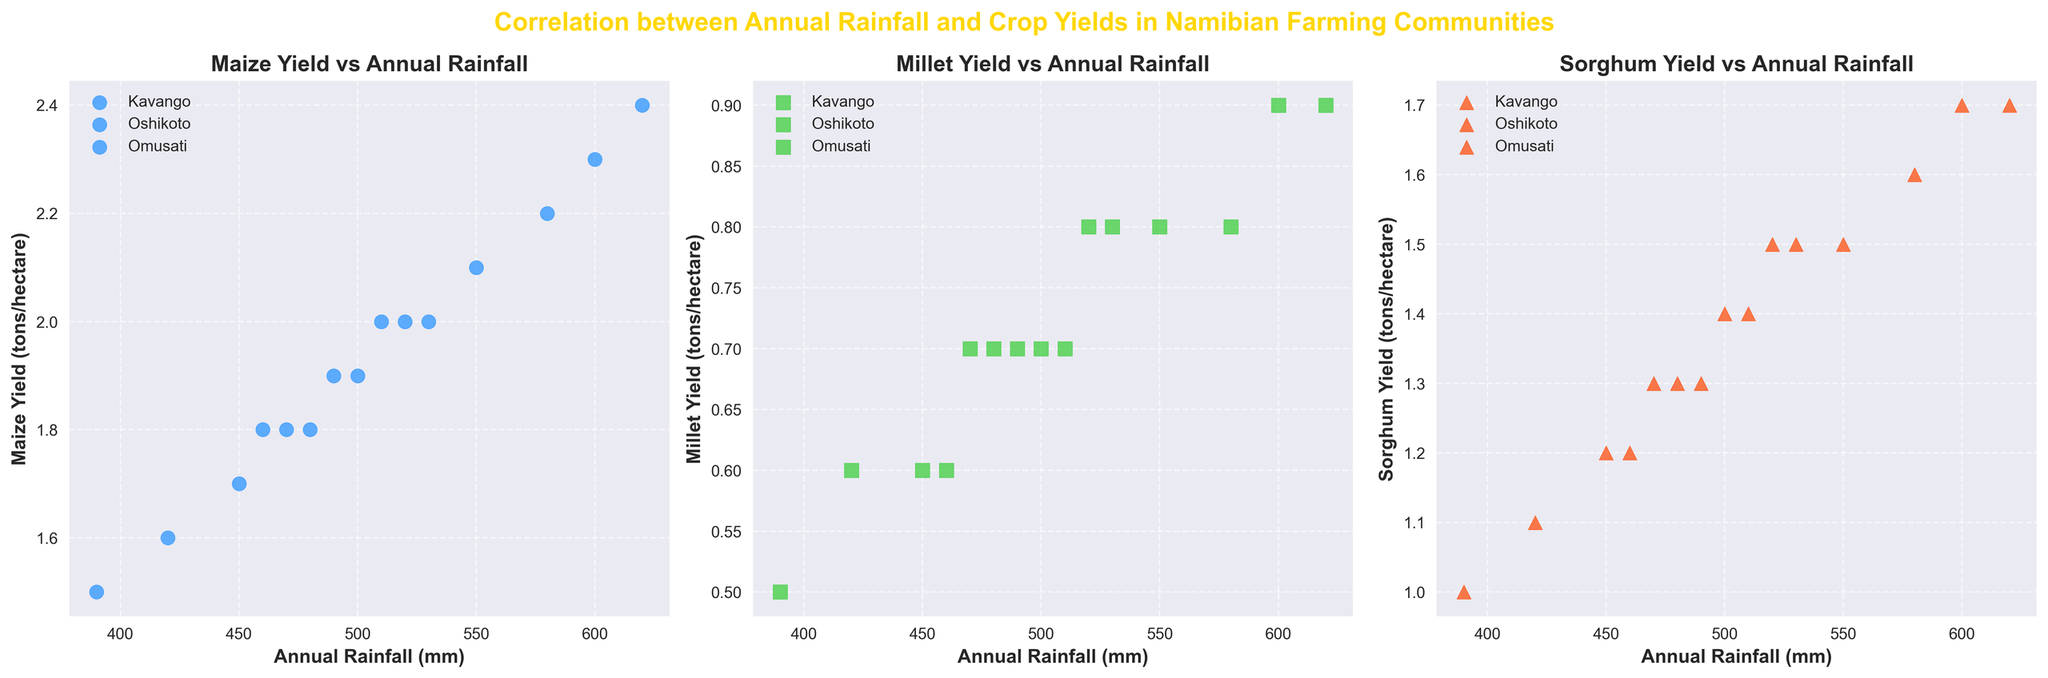Which crop shows the highest yield per hectare at the maximum annual rainfall observed? First, identify the crop plots and find the maximum annual rainfall on the x-axis. Then, check the corresponding yield for each crop.
Answer: Maize Which region consistently shows higher yields for maize across the years? Observe the scatter plot for maize and compare the data points for different regions. Kavango consistently has higher maize yields.
Answer: Kavango What is the general trend between rainfall and millet yield? Examine the scatter plot for millet and note the overall direction of the data points. As rainfall increases, the millet yield also seems to increase.
Answer: Increasing In which year did Omusati have the lowest sorghum yield, and what was the annual rainfall? Look at the sorghum scatter plot and find the lowest yield point for Omusati, then check the year and rainfall for that point.
Answer: 2020, 390 mm Between Kavango and Oshikoto, which region had a higher millet yield at approximately 500 mm annual rainfall? Check the millet scatter plot and identify data points near 500 mm for both regions, then compare the yields.
Answer: Kavango What can you infer about the correlation between rainfall and crop yields for each of the three crops? Analyze the scatter plots for each crop and determine whether there is a positive, negative, or no clear correlation.
Answer: Positive correlation How do the sorghum yields compare to maize yields for the same annual rainfall in 2021? For 2021, find data points in both maize and sorghum plots at similar rainfall levels, and compare their yields. Maize generally has higher yields than sorghum at the same rainfall level.
Answer: Maize yields are higher Considering all regions, which crop seems least affected by annual rainfall variations? Compare the scatter plots and observe which crop has the least variation in yields with varying rainfall.
Answer: Millet At 600 mm rainfall in Kavango, how do the yields of maize and millet compare? Locate the data points for 600 mm rainfall for Kavango in both maize and millet plots and compare their yields.
Answer: Maize yield is higher 